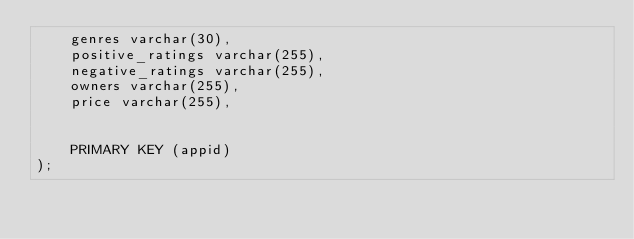Convert code to text. <code><loc_0><loc_0><loc_500><loc_500><_SQL_>	genres varchar(30),
	positive_ratings varchar(255),
	negative_ratings varchar(255),
	owners varchar(255),
	price varchar(255),
	
	
	PRIMARY KEY (appid)
);</code> 